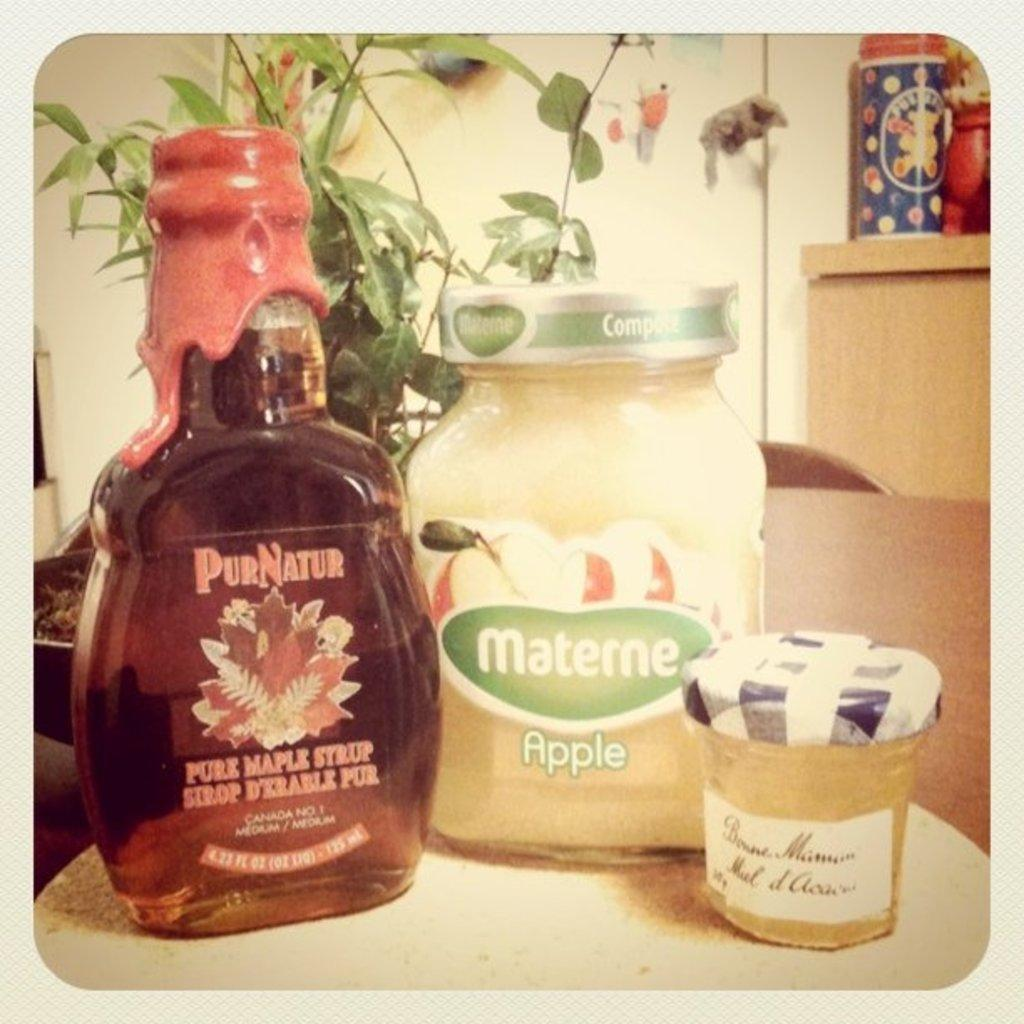<image>
Describe the image concisely. A jar of apple compote next to some maple syrup and a small jar of jelly. 